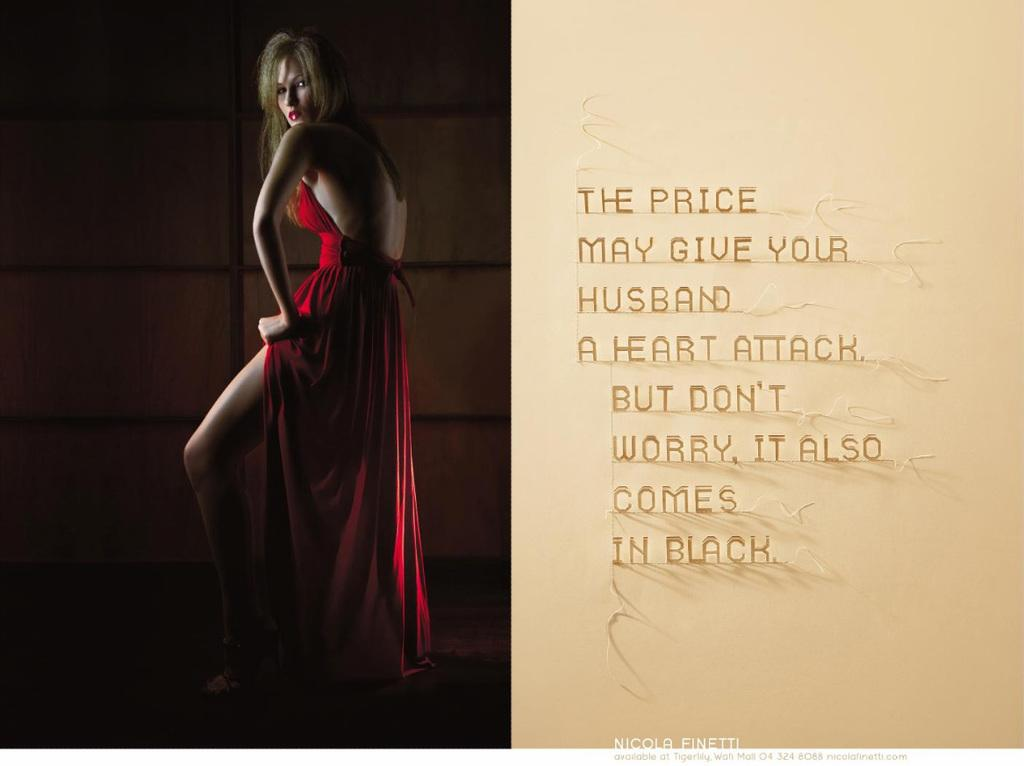What is the main object in the image? There is a poster in the image. What can be seen on the left side of the poster? The poster includes an image of a woman on the left side. What is present on the right side of the poster? There is text on the right side of the poster. What type of smile can be seen on the judge's face in the image? There is no judge or smile present in the image; it only features a poster with an image of a woman and text. 